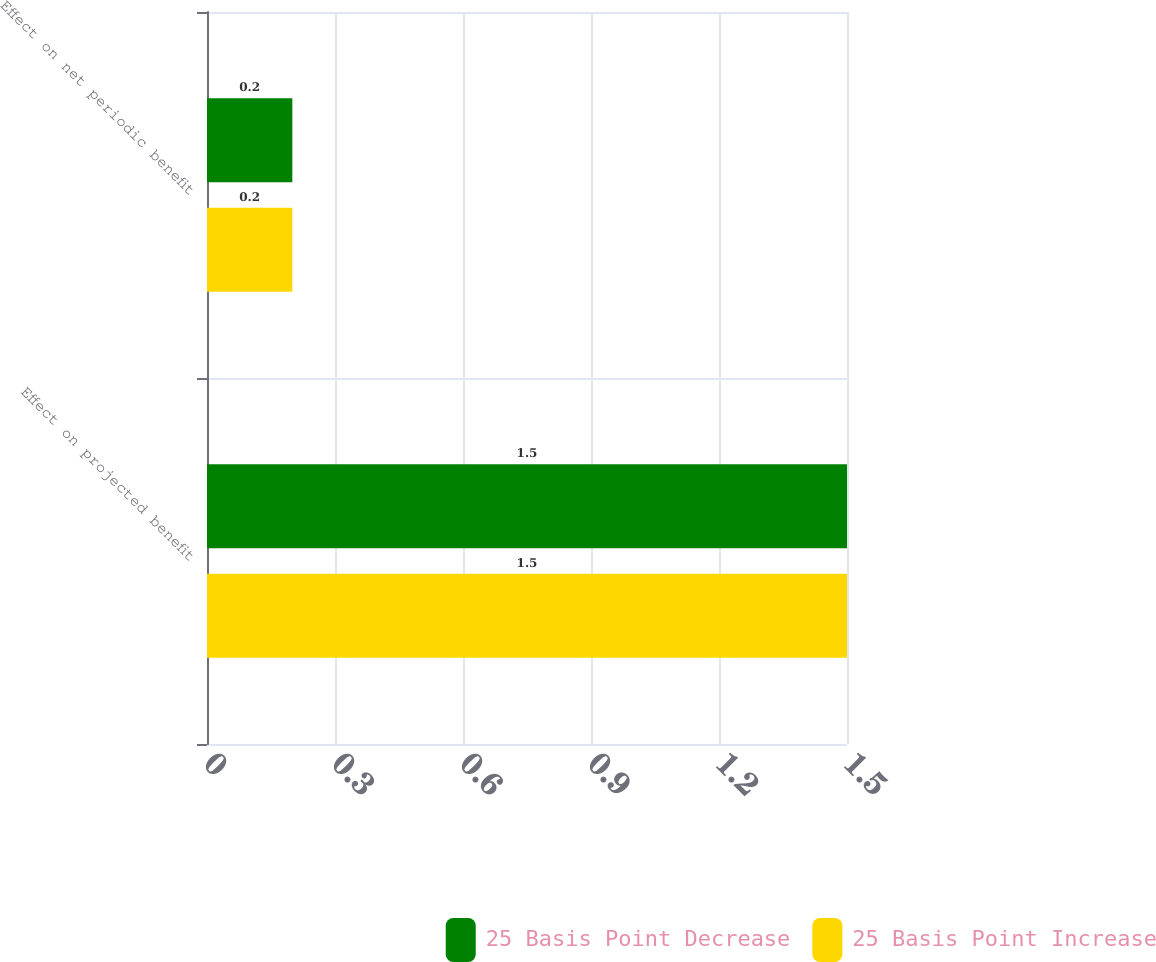Convert chart to OTSL. <chart><loc_0><loc_0><loc_500><loc_500><stacked_bar_chart><ecel><fcel>Effect on projected benefit<fcel>Effect on net periodic benefit<nl><fcel>25 Basis Point Decrease<fcel>1.5<fcel>0.2<nl><fcel>25 Basis Point Increase<fcel>1.5<fcel>0.2<nl></chart> 